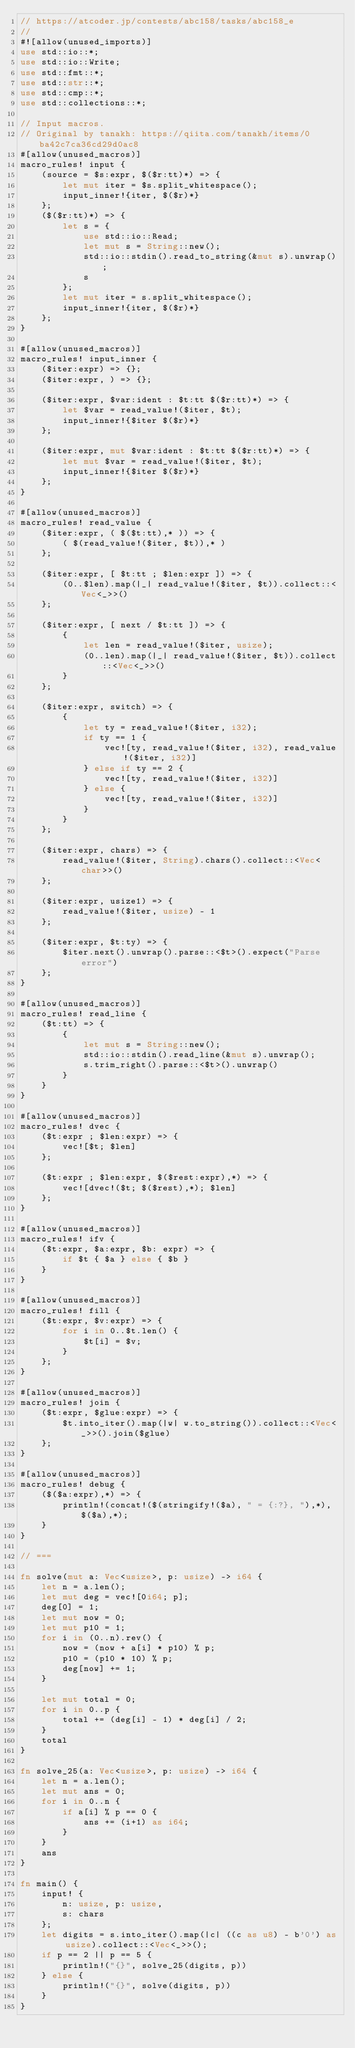<code> <loc_0><loc_0><loc_500><loc_500><_Rust_>// https://atcoder.jp/contests/abc158/tasks/abc158_e
//
#![allow(unused_imports)]
use std::io::*;
use std::io::Write;
use std::fmt::*;
use std::str::*;
use std::cmp::*;
use std::collections::*;

// Input macros.
// Original by tanakh: https://qiita.com/tanakh/items/0ba42c7ca36cd29d0ac8
#[allow(unused_macros)]
macro_rules! input {
    (source = $s:expr, $($r:tt)*) => {
        let mut iter = $s.split_whitespace();
        input_inner!{iter, $($r)*}
    };
    ($($r:tt)*) => {
        let s = {
            use std::io::Read;
            let mut s = String::new();
            std::io::stdin().read_to_string(&mut s).unwrap();
            s
        };
        let mut iter = s.split_whitespace();
        input_inner!{iter, $($r)*}
    };
}

#[allow(unused_macros)]
macro_rules! input_inner {
    ($iter:expr) => {};
    ($iter:expr, ) => {};

    ($iter:expr, $var:ident : $t:tt $($r:tt)*) => {
        let $var = read_value!($iter, $t);
        input_inner!{$iter $($r)*}
    };

    ($iter:expr, mut $var:ident : $t:tt $($r:tt)*) => {
        let mut $var = read_value!($iter, $t);
        input_inner!{$iter $($r)*}
    };
}

#[allow(unused_macros)]
macro_rules! read_value {
    ($iter:expr, ( $($t:tt),* )) => {
        ( $(read_value!($iter, $t)),* )
    };

    ($iter:expr, [ $t:tt ; $len:expr ]) => {
        (0..$len).map(|_| read_value!($iter, $t)).collect::<Vec<_>>()
    };

    ($iter:expr, [ next / $t:tt ]) => {
        {
            let len = read_value!($iter, usize);
            (0..len).map(|_| read_value!($iter, $t)).collect::<Vec<_>>()
        }
    };

    ($iter:expr, switch) => {
        {
            let ty = read_value!($iter, i32);
            if ty == 1 {
                vec![ty, read_value!($iter, i32), read_value!($iter, i32)]
            } else if ty == 2 {
                vec![ty, read_value!($iter, i32)]
            } else {
                vec![ty, read_value!($iter, i32)]
            }
        }
    };

    ($iter:expr, chars) => {
        read_value!($iter, String).chars().collect::<Vec<char>>()
    };

    ($iter:expr, usize1) => {
        read_value!($iter, usize) - 1
    };

    ($iter:expr, $t:ty) => {
        $iter.next().unwrap().parse::<$t>().expect("Parse error")
    };
}

#[allow(unused_macros)]
macro_rules! read_line {
    ($t:tt) => {
        {
            let mut s = String::new();
            std::io::stdin().read_line(&mut s).unwrap();
            s.trim_right().parse::<$t>().unwrap()
        }
    }
}

#[allow(unused_macros)]
macro_rules! dvec {
    ($t:expr ; $len:expr) => {
        vec![$t; $len]
    };

    ($t:expr ; $len:expr, $($rest:expr),*) => {
        vec![dvec!($t; $($rest),*); $len]
    };
}

#[allow(unused_macros)]
macro_rules! ifv {
    ($t:expr, $a:expr, $b: expr) => {
        if $t { $a } else { $b }
    }
}

#[allow(unused_macros)]
macro_rules! fill {
    ($t:expr, $v:expr) => {
        for i in 0..$t.len() {
            $t[i] = $v;
        }
    };
}

#[allow(unused_macros)]
macro_rules! join {
    ($t:expr, $glue:expr) => {
        $t.into_iter().map(|w| w.to_string()).collect::<Vec<_>>().join($glue)
    };
}

#[allow(unused_macros)]
macro_rules! debug {
    ($($a:expr),*) => {
        println!(concat!($(stringify!($a), " = {:?}, "),*), $($a),*);
    }
}

// ===

fn solve(mut a: Vec<usize>, p: usize) -> i64 {
    let n = a.len();
    let mut deg = vec![0i64; p];
    deg[0] = 1;
    let mut now = 0;
    let mut p10 = 1;
    for i in (0..n).rev() {
        now = (now + a[i] * p10) % p;
        p10 = (p10 * 10) % p;
        deg[now] += 1;
    }

    let mut total = 0;
    for i in 0..p {
        total += (deg[i] - 1) * deg[i] / 2;
    }
    total
}

fn solve_25(a: Vec<usize>, p: usize) -> i64 {
    let n = a.len();
    let mut ans = 0;
    for i in 0..n {
        if a[i] % p == 0 {
            ans += (i+1) as i64;
        }
    }
    ans
}

fn main() {
    input! {
        n: usize, p: usize,
        s: chars
    };
    let digits = s.into_iter().map(|c| ((c as u8) - b'0') as usize).collect::<Vec<_>>();
    if p == 2 || p == 5 {
        println!("{}", solve_25(digits, p))
    } else {
        println!("{}", solve(digits, p))
    }
}
</code> 